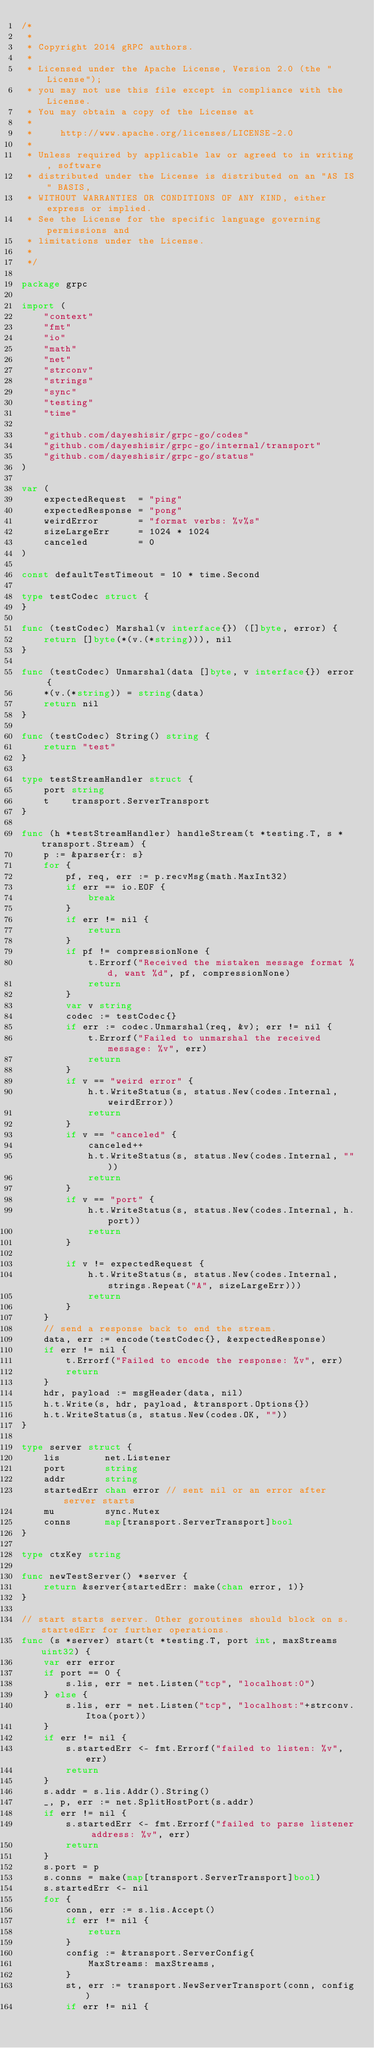<code> <loc_0><loc_0><loc_500><loc_500><_Go_>/*
 *
 * Copyright 2014 gRPC authors.
 *
 * Licensed under the Apache License, Version 2.0 (the "License");
 * you may not use this file except in compliance with the License.
 * You may obtain a copy of the License at
 *
 *     http://www.apache.org/licenses/LICENSE-2.0
 *
 * Unless required by applicable law or agreed to in writing, software
 * distributed under the License is distributed on an "AS IS" BASIS,
 * WITHOUT WARRANTIES OR CONDITIONS OF ANY KIND, either express or implied.
 * See the License for the specific language governing permissions and
 * limitations under the License.
 *
 */

package grpc

import (
	"context"
	"fmt"
	"io"
	"math"
	"net"
	"strconv"
	"strings"
	"sync"
	"testing"
	"time"

	"github.com/dayeshisir/grpc-go/codes"
	"github.com/dayeshisir/grpc-go/internal/transport"
	"github.com/dayeshisir/grpc-go/status"
)

var (
	expectedRequest  = "ping"
	expectedResponse = "pong"
	weirdError       = "format verbs: %v%s"
	sizeLargeErr     = 1024 * 1024
	canceled         = 0
)

const defaultTestTimeout = 10 * time.Second

type testCodec struct {
}

func (testCodec) Marshal(v interface{}) ([]byte, error) {
	return []byte(*(v.(*string))), nil
}

func (testCodec) Unmarshal(data []byte, v interface{}) error {
	*(v.(*string)) = string(data)
	return nil
}

func (testCodec) String() string {
	return "test"
}

type testStreamHandler struct {
	port string
	t    transport.ServerTransport
}

func (h *testStreamHandler) handleStream(t *testing.T, s *transport.Stream) {
	p := &parser{r: s}
	for {
		pf, req, err := p.recvMsg(math.MaxInt32)
		if err == io.EOF {
			break
		}
		if err != nil {
			return
		}
		if pf != compressionNone {
			t.Errorf("Received the mistaken message format %d, want %d", pf, compressionNone)
			return
		}
		var v string
		codec := testCodec{}
		if err := codec.Unmarshal(req, &v); err != nil {
			t.Errorf("Failed to unmarshal the received message: %v", err)
			return
		}
		if v == "weird error" {
			h.t.WriteStatus(s, status.New(codes.Internal, weirdError))
			return
		}
		if v == "canceled" {
			canceled++
			h.t.WriteStatus(s, status.New(codes.Internal, ""))
			return
		}
		if v == "port" {
			h.t.WriteStatus(s, status.New(codes.Internal, h.port))
			return
		}

		if v != expectedRequest {
			h.t.WriteStatus(s, status.New(codes.Internal, strings.Repeat("A", sizeLargeErr)))
			return
		}
	}
	// send a response back to end the stream.
	data, err := encode(testCodec{}, &expectedResponse)
	if err != nil {
		t.Errorf("Failed to encode the response: %v", err)
		return
	}
	hdr, payload := msgHeader(data, nil)
	h.t.Write(s, hdr, payload, &transport.Options{})
	h.t.WriteStatus(s, status.New(codes.OK, ""))
}

type server struct {
	lis        net.Listener
	port       string
	addr       string
	startedErr chan error // sent nil or an error after server starts
	mu         sync.Mutex
	conns      map[transport.ServerTransport]bool
}

type ctxKey string

func newTestServer() *server {
	return &server{startedErr: make(chan error, 1)}
}

// start starts server. Other goroutines should block on s.startedErr for further operations.
func (s *server) start(t *testing.T, port int, maxStreams uint32) {
	var err error
	if port == 0 {
		s.lis, err = net.Listen("tcp", "localhost:0")
	} else {
		s.lis, err = net.Listen("tcp", "localhost:"+strconv.Itoa(port))
	}
	if err != nil {
		s.startedErr <- fmt.Errorf("failed to listen: %v", err)
		return
	}
	s.addr = s.lis.Addr().String()
	_, p, err := net.SplitHostPort(s.addr)
	if err != nil {
		s.startedErr <- fmt.Errorf("failed to parse listener address: %v", err)
		return
	}
	s.port = p
	s.conns = make(map[transport.ServerTransport]bool)
	s.startedErr <- nil
	for {
		conn, err := s.lis.Accept()
		if err != nil {
			return
		}
		config := &transport.ServerConfig{
			MaxStreams: maxStreams,
		}
		st, err := transport.NewServerTransport(conn, config)
		if err != nil {</code> 